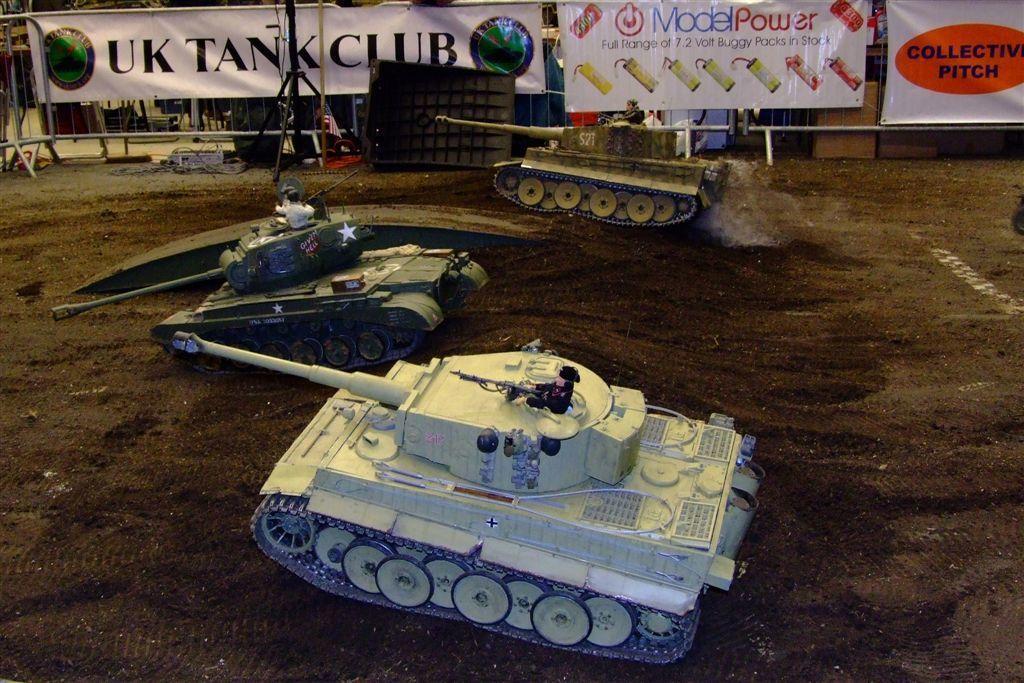Please provide a concise description of this image. In this picture we can see miniatures of military tanks, in the background there are barricades, we can see banners in the middle, we can see a tripod on the left side, at the bottom there is soil. 